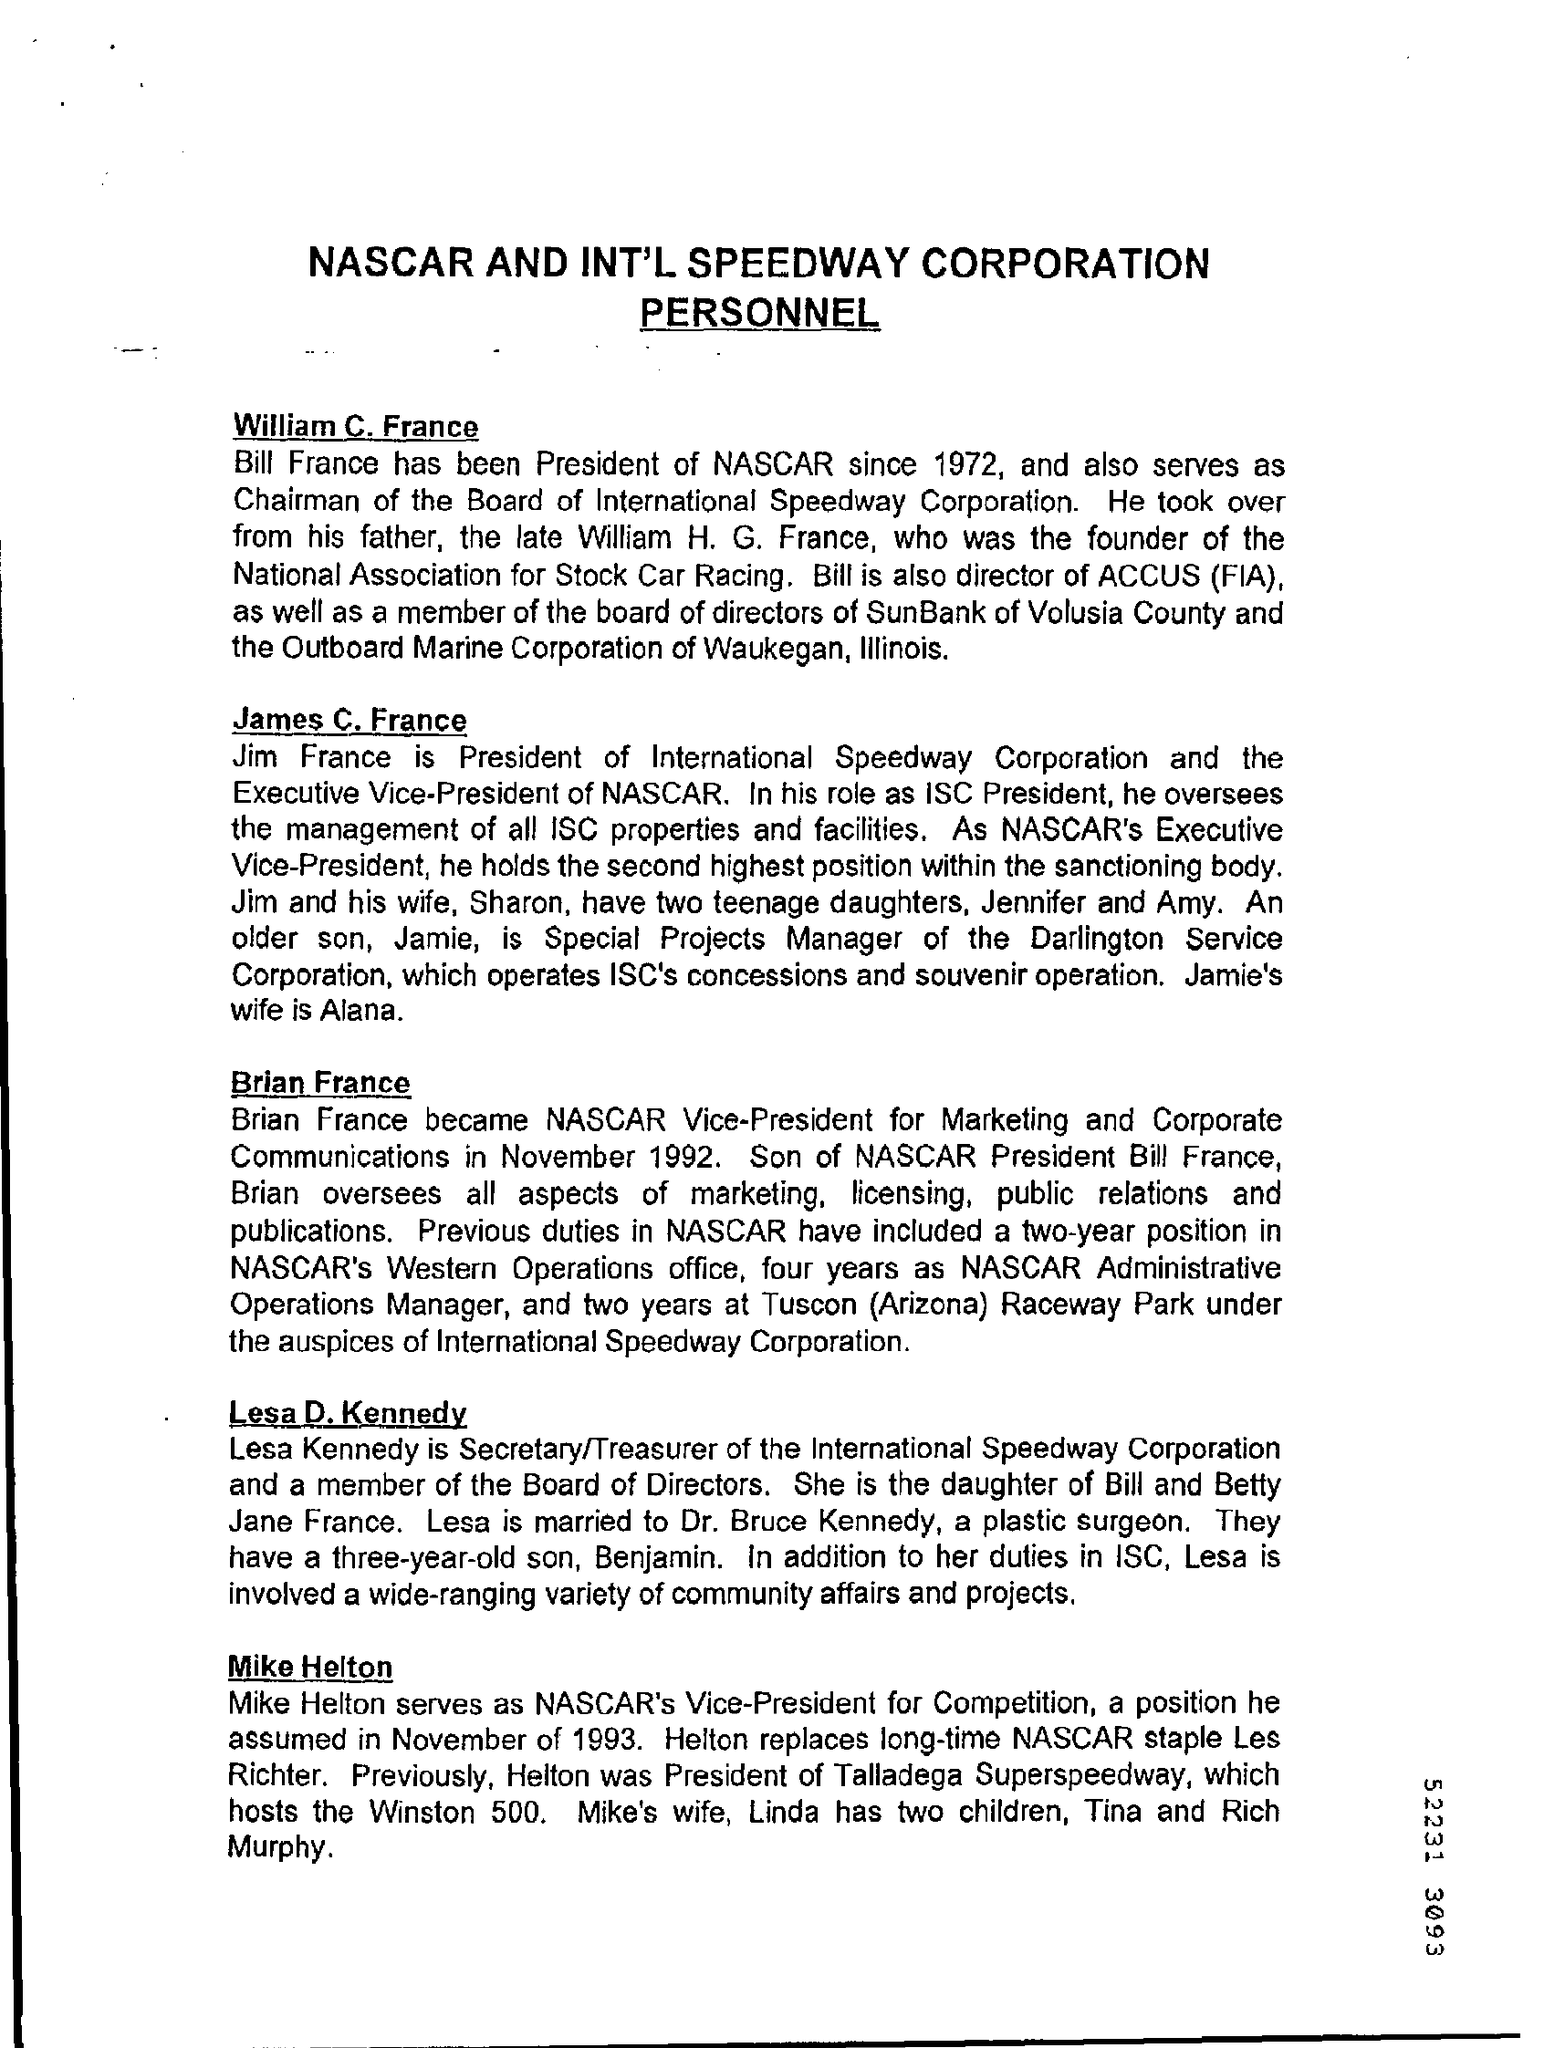Who is son of Bill France?
Offer a very short reply. Brian france. From which year Bill france became the president of NASCAR?
Your answer should be very brief. 1972. 